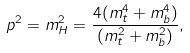Convert formula to latex. <formula><loc_0><loc_0><loc_500><loc_500>p ^ { 2 } = m _ { H } ^ { 2 } = \frac { 4 ( m _ { t } ^ { 4 } + m _ { b } ^ { 4 } ) } { ( m _ { t } ^ { 2 } + m _ { b } ^ { 2 } ) } ,</formula> 